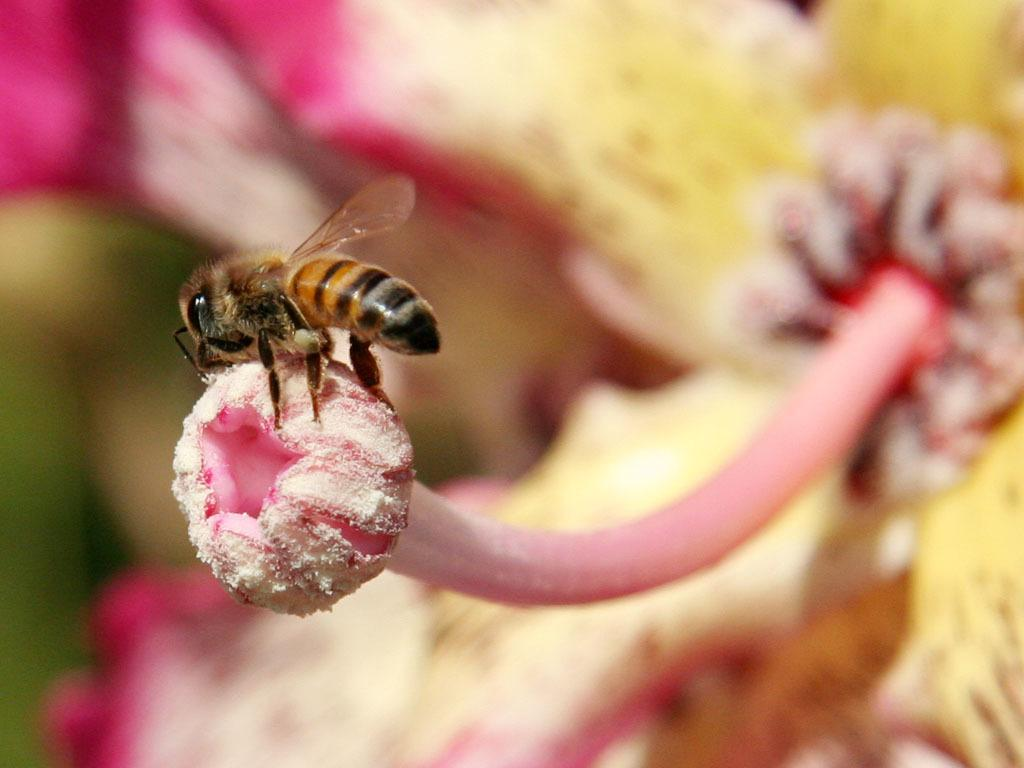What type of creature can be seen in the image? There is an insect in the image. What is the insect interacting with in the image? The insect is interacting with a flower in the image. Can you describe the background of the image? The background of the image is blurred. What advice does the carpenter give to the insect in the image? There is no carpenter present in the image, and therefore no advice can be given. 